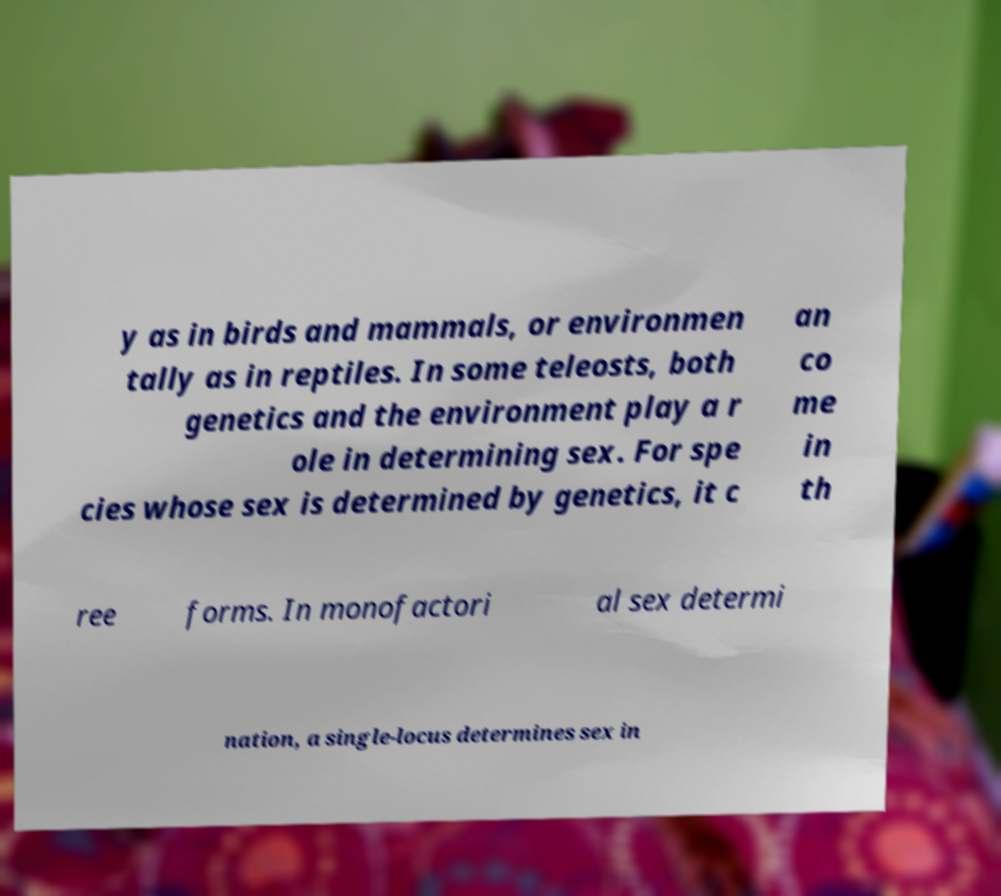I need the written content from this picture converted into text. Can you do that? y as in birds and mammals, or environmen tally as in reptiles. In some teleosts, both genetics and the environment play a r ole in determining sex. For spe cies whose sex is determined by genetics, it c an co me in th ree forms. In monofactori al sex determi nation, a single-locus determines sex in 